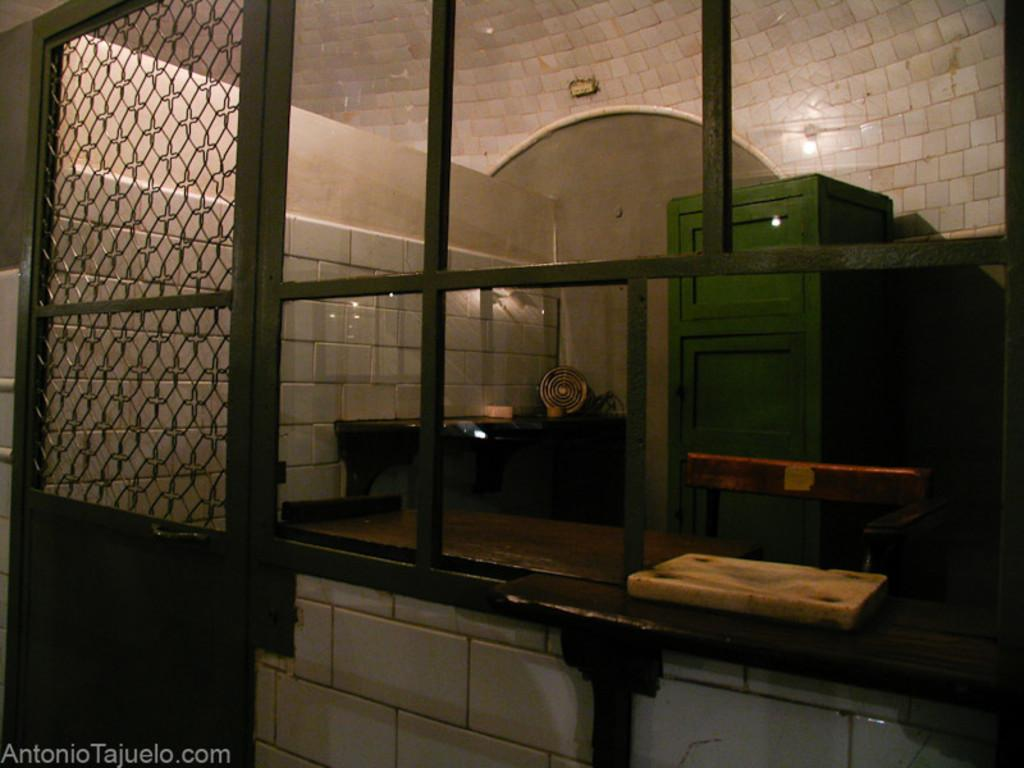What color is the door in the room? The door in the room is green. What color are the tiles in the room? The tiles in the room are white. Are there any other green objects in the room besides the door? Yes, there is a green box in the room. Can you see any worms crawling on the floor in the image? There is no mention of a floor or worms in the provided facts, so we cannot determine if there are any worms present in the image. 